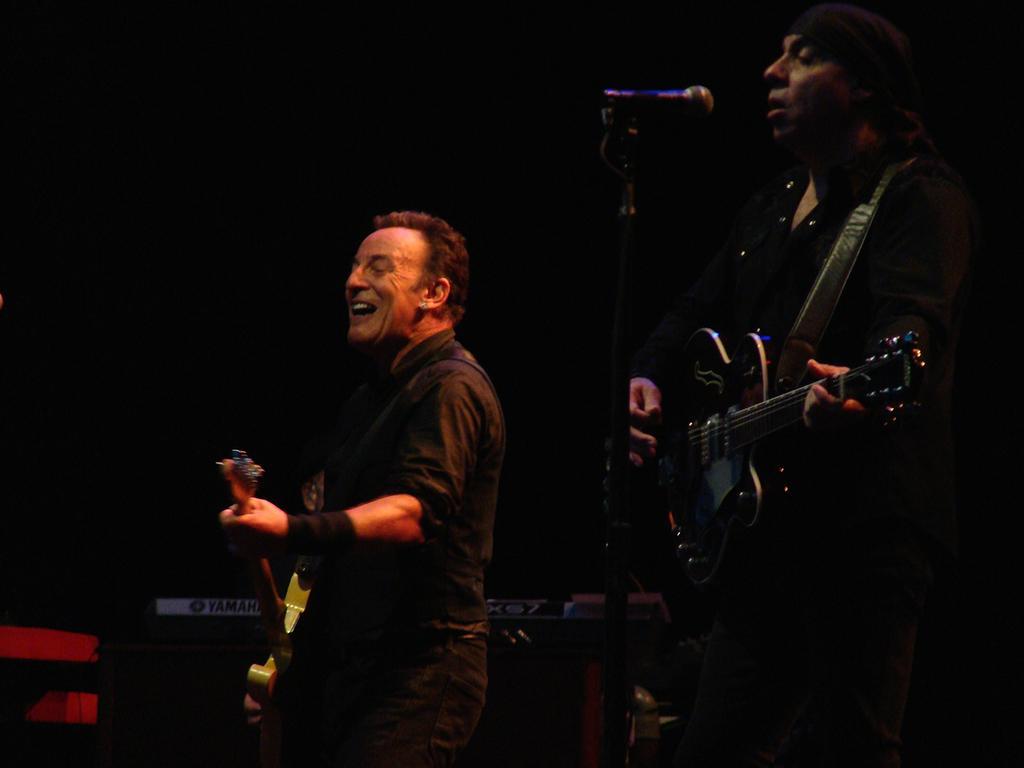Can you describe this image briefly? In this image I see 2 persons who are holding the guitar and this person is standing in front of a mic. 